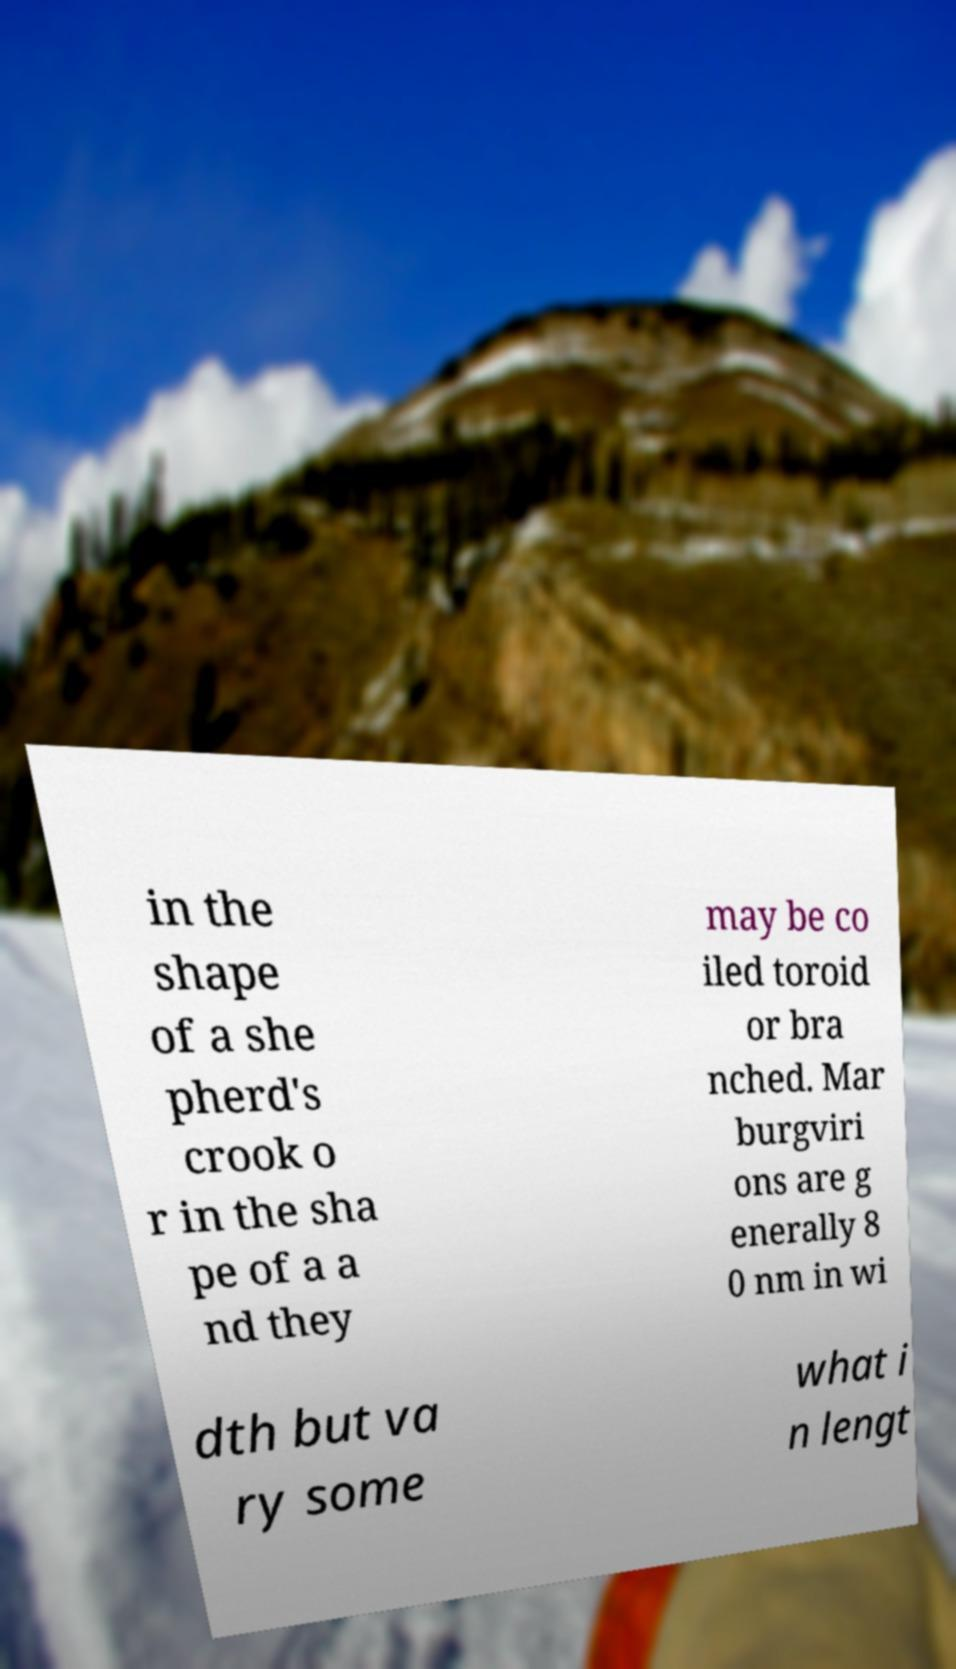Could you extract and type out the text from this image? in the shape of a she pherd's crook o r in the sha pe of a a nd they may be co iled toroid or bra nched. Mar burgviri ons are g enerally 8 0 nm in wi dth but va ry some what i n lengt 